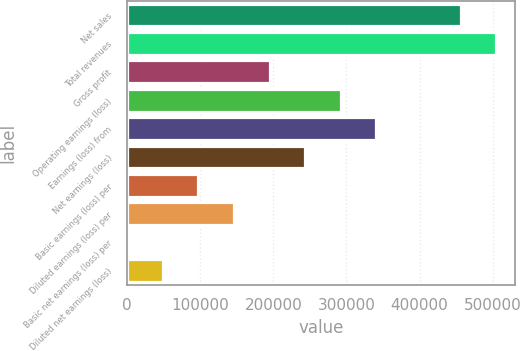<chart> <loc_0><loc_0><loc_500><loc_500><bar_chart><fcel>Net sales<fcel>Total revenues<fcel>Gross profit<fcel>Operating earnings (loss)<fcel>Earnings (loss) from<fcel>Net earnings (loss)<fcel>Basic earnings (loss) per<fcel>Diluted earnings (loss) per<fcel>Basic net earnings (loss) per<fcel>Diluted net earnings (loss)<nl><fcel>456316<fcel>505036<fcel>194880<fcel>292320<fcel>341040<fcel>243600<fcel>97440.3<fcel>146160<fcel>0.42<fcel>48720.4<nl></chart> 